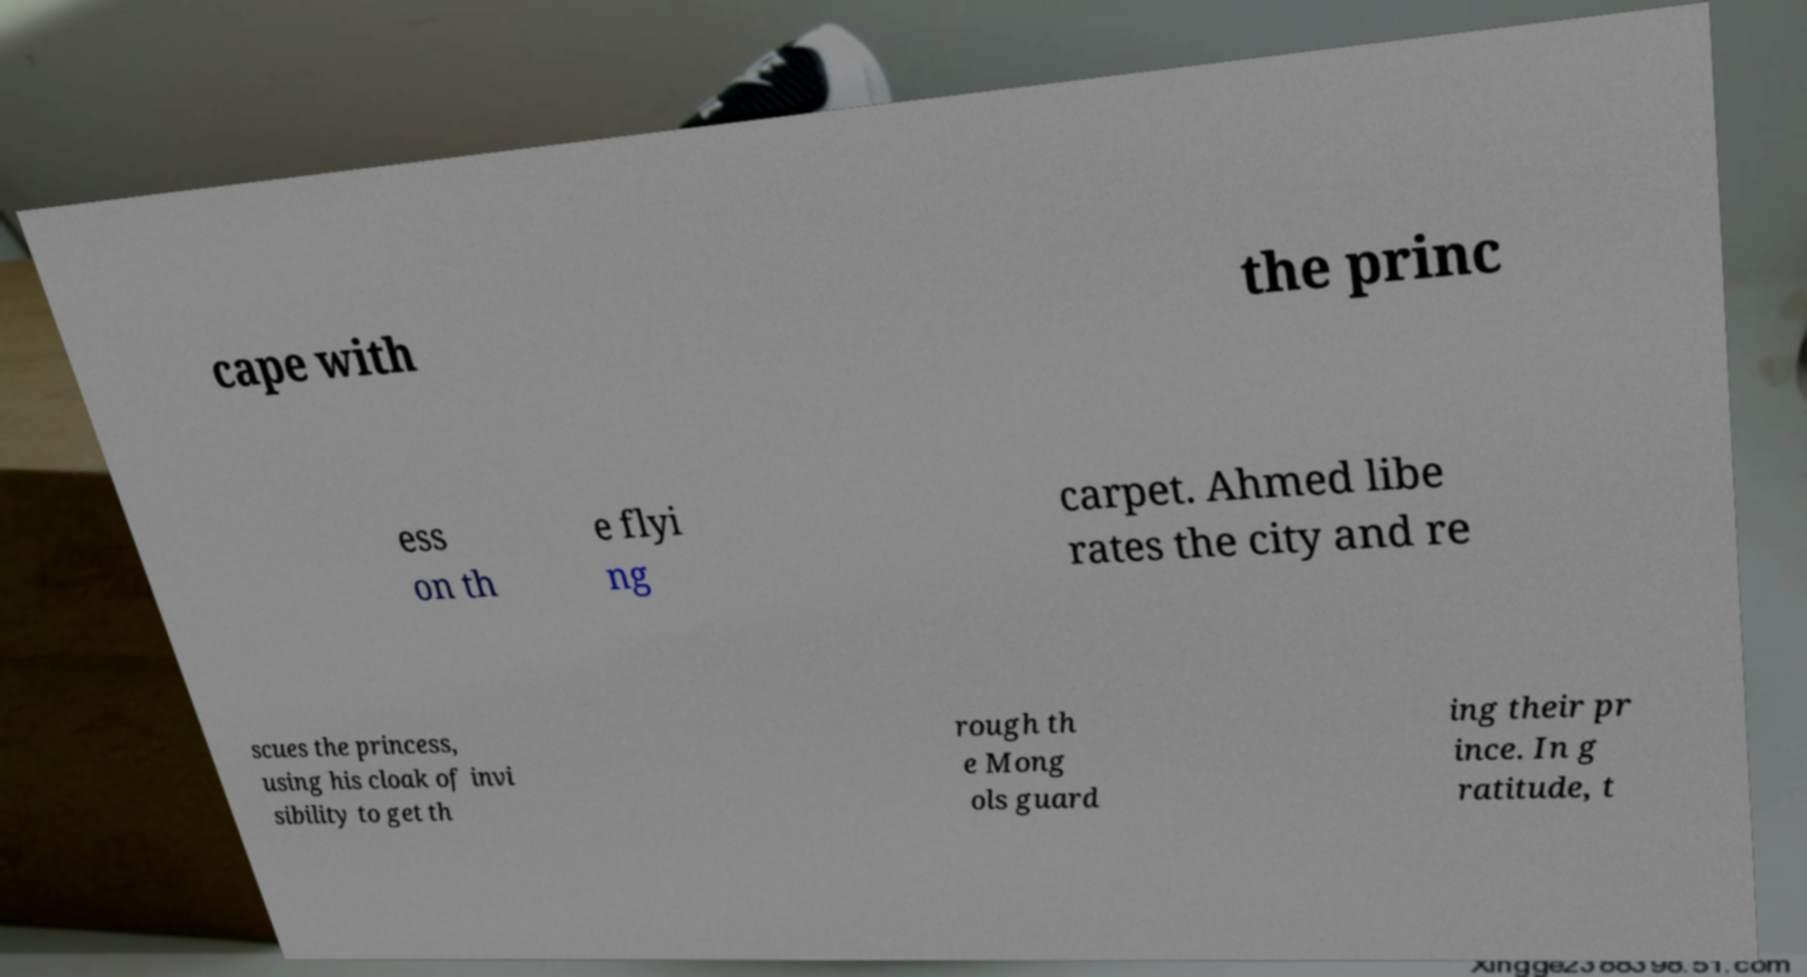For documentation purposes, I need the text within this image transcribed. Could you provide that? cape with the princ ess on th e flyi ng carpet. Ahmed libe rates the city and re scues the princess, using his cloak of invi sibility to get th rough th e Mong ols guard ing their pr ince. In g ratitude, t 